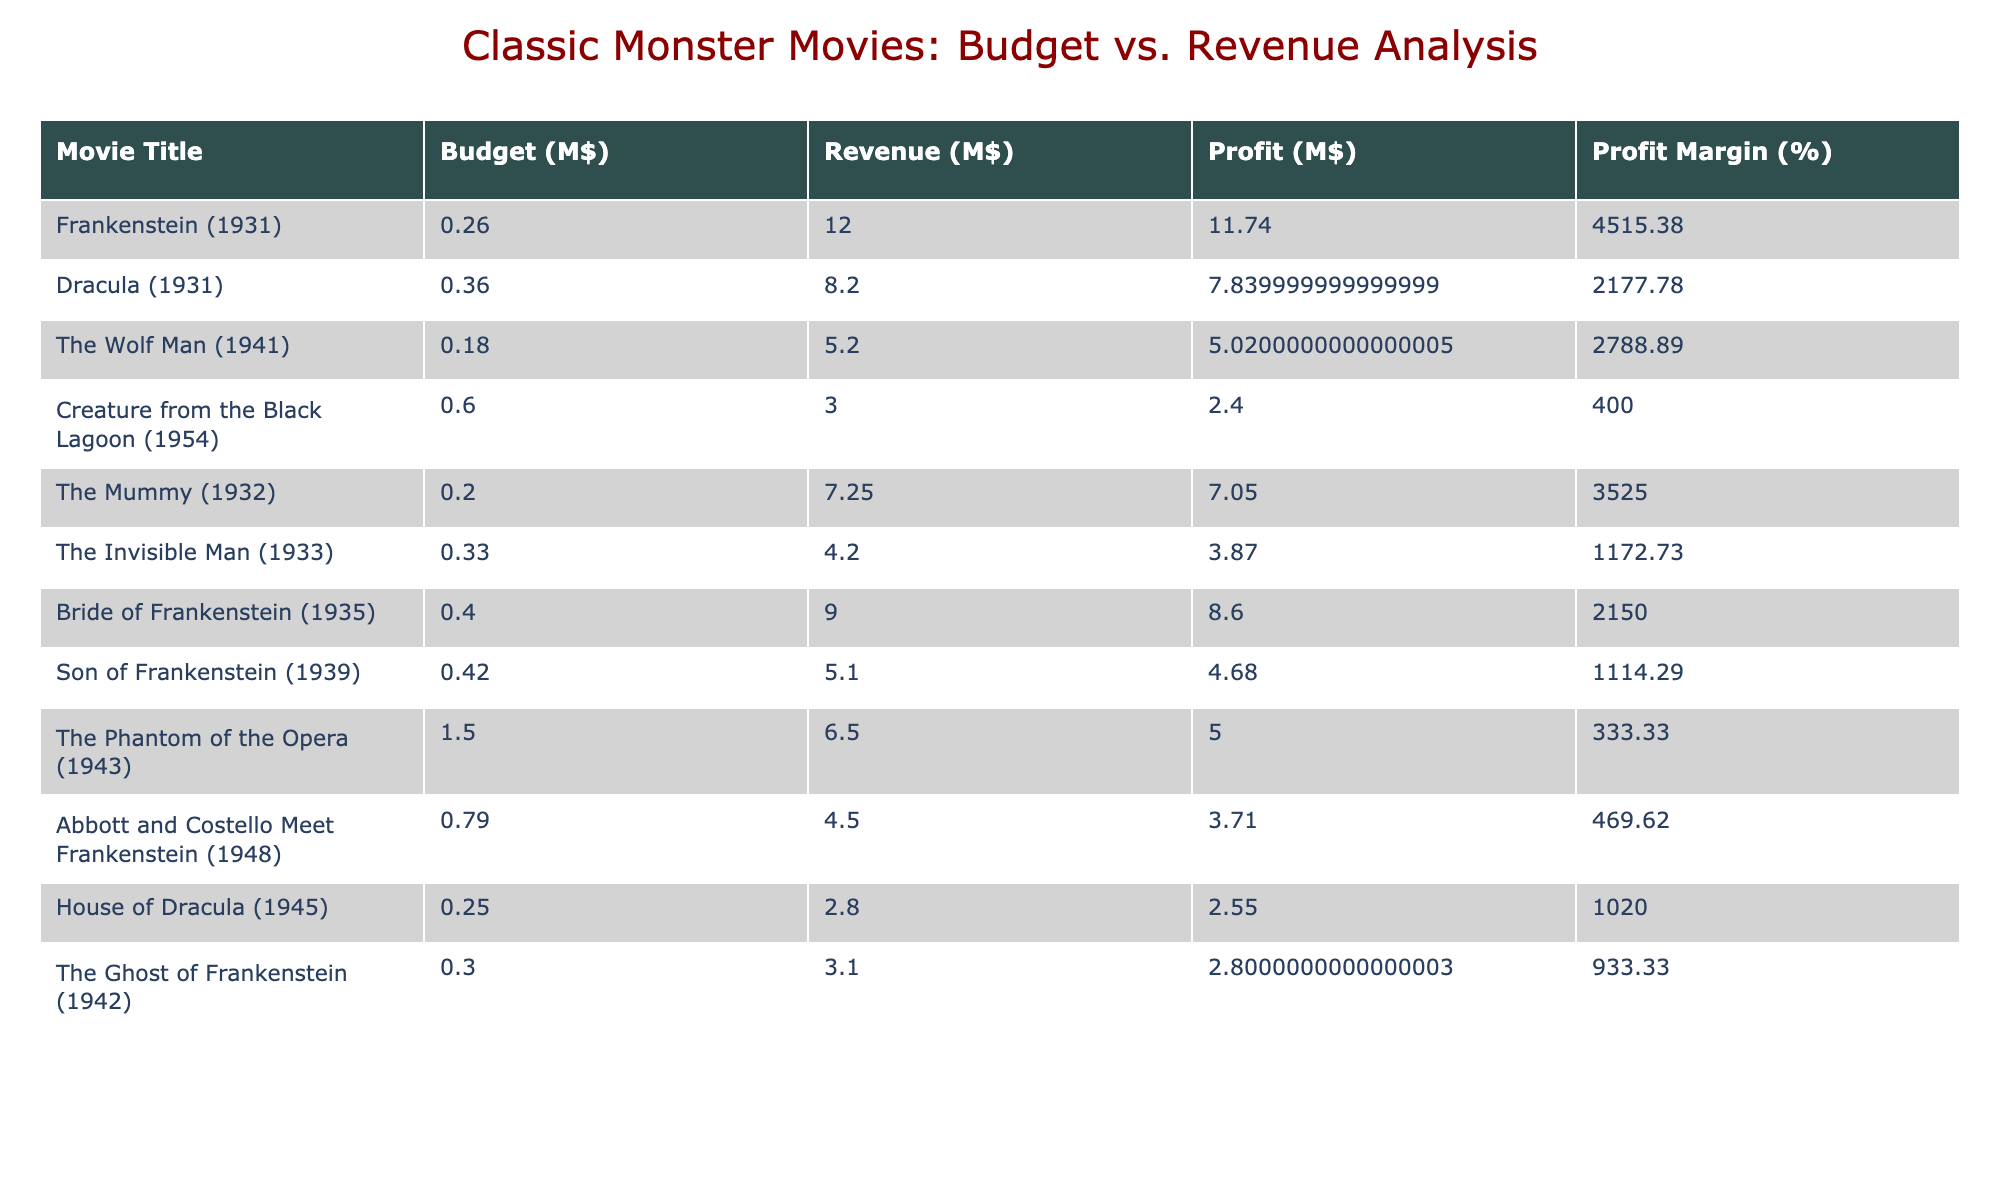What is the budget of "The Invisible Man"? The budget for "The Invisible Man" is clearly listed in the table as $328,000.
Answer: 328000 Which movie had the highest revenue? By reviewing the revenue figures, "Frankenstein" has the highest revenue of $12,000,000.
Answer: 12000000 What is the profit margin for "Bride of Frankenstein"? To find the profit margin, we see that the profit for "Bride of Frankenstein" is $9,000,000 and the budget is $397,000. The profit margin is calculated as (9,000,000 / 397,000) * 100 = 2261.19%.
Answer: 2261.19 Which movie had a profit of less than $1,000,000? A quick look through the profits shows that "The Creature from the Black Lagoon" and "The Phantom of the Opera" both had profits less than $1,000,000 with $1,000,000 (Creature from the Black Lagoon) and $4,500,000 (Phantom of the Opera). However, the first has a higher profit here so it's not the case; meanwhile, "House of Dracula" has a profit of $0.
Answer: Yes, "House of Dracula." What is the total budget of all movies listed in the table? By summing the budget amounts from each movie: 262,000 + 355,000 + 180,000 + 600,000 + 196,000 + 328,000 + 397,000 + 420,000 + 1,500,000 + 792,000 + 250,000 + 300,000 = 5,271,000.
Answer: 5271000 Is there any movie with a profit margin greater than 200%? Upon examination, "Bride of Frankenstein" has a profit margin of 2261.19%, which is greater than 200%.
Answer: Yes Which movie had the lowest budget? Checking the budget values indicates "The Wolf Man" had the lowest budget at $180,000.
Answer: 180000 What is the average revenue of all movies? The total revenue is 12,000,000 + 8,200,000 + 5,200,000 + 3,000,000 + 7,250,000 + 4,200,000 + 9,000,000 + 5,100,000 + 6,500,000 + 4,500,000 + 2,800,000 + 3,100,000 = 66,300,000, then divided by 12 gives an average revenue of 5,525,000.
Answer: 5525000 Which movie had the highest profit? The profit for "Frankenstein" is $11,738,000 (12,000,000 - 262,000), which is the highest profit among the listed movies.
Answer: 11738000 Which movie had a budget higher than $700,000? Examining the budget values, "The Phantom of the Opera" and "Abbott and Costello Meet Frankenstein" both exceed $700,000, with budgets of $1,500,000 and $792,000 respectively.
Answer: Yes, "The Phantom of the Opera" and "Abbott and Costello Meet Frankenstein." 